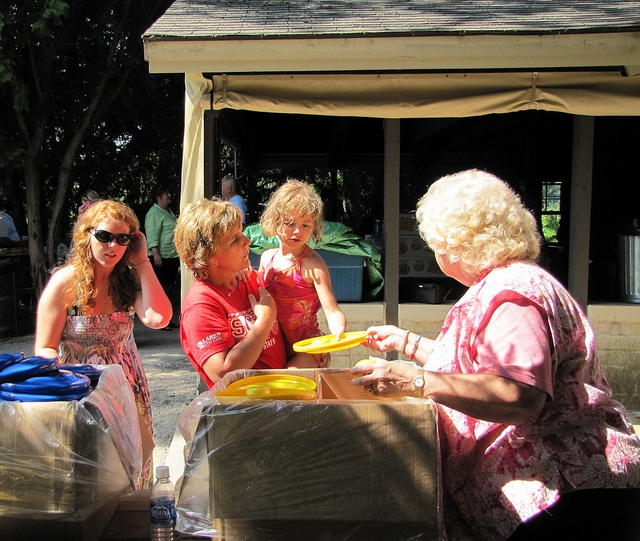Describe the objects in this image and their specific colors. I can see people in black, white, maroon, and lightpink tones, people in black, brown, salmon, and tan tones, people in black, brown, and salmon tones, people in black, brown, ivory, and tan tones, and people in black, teal, and darkgreen tones in this image. 